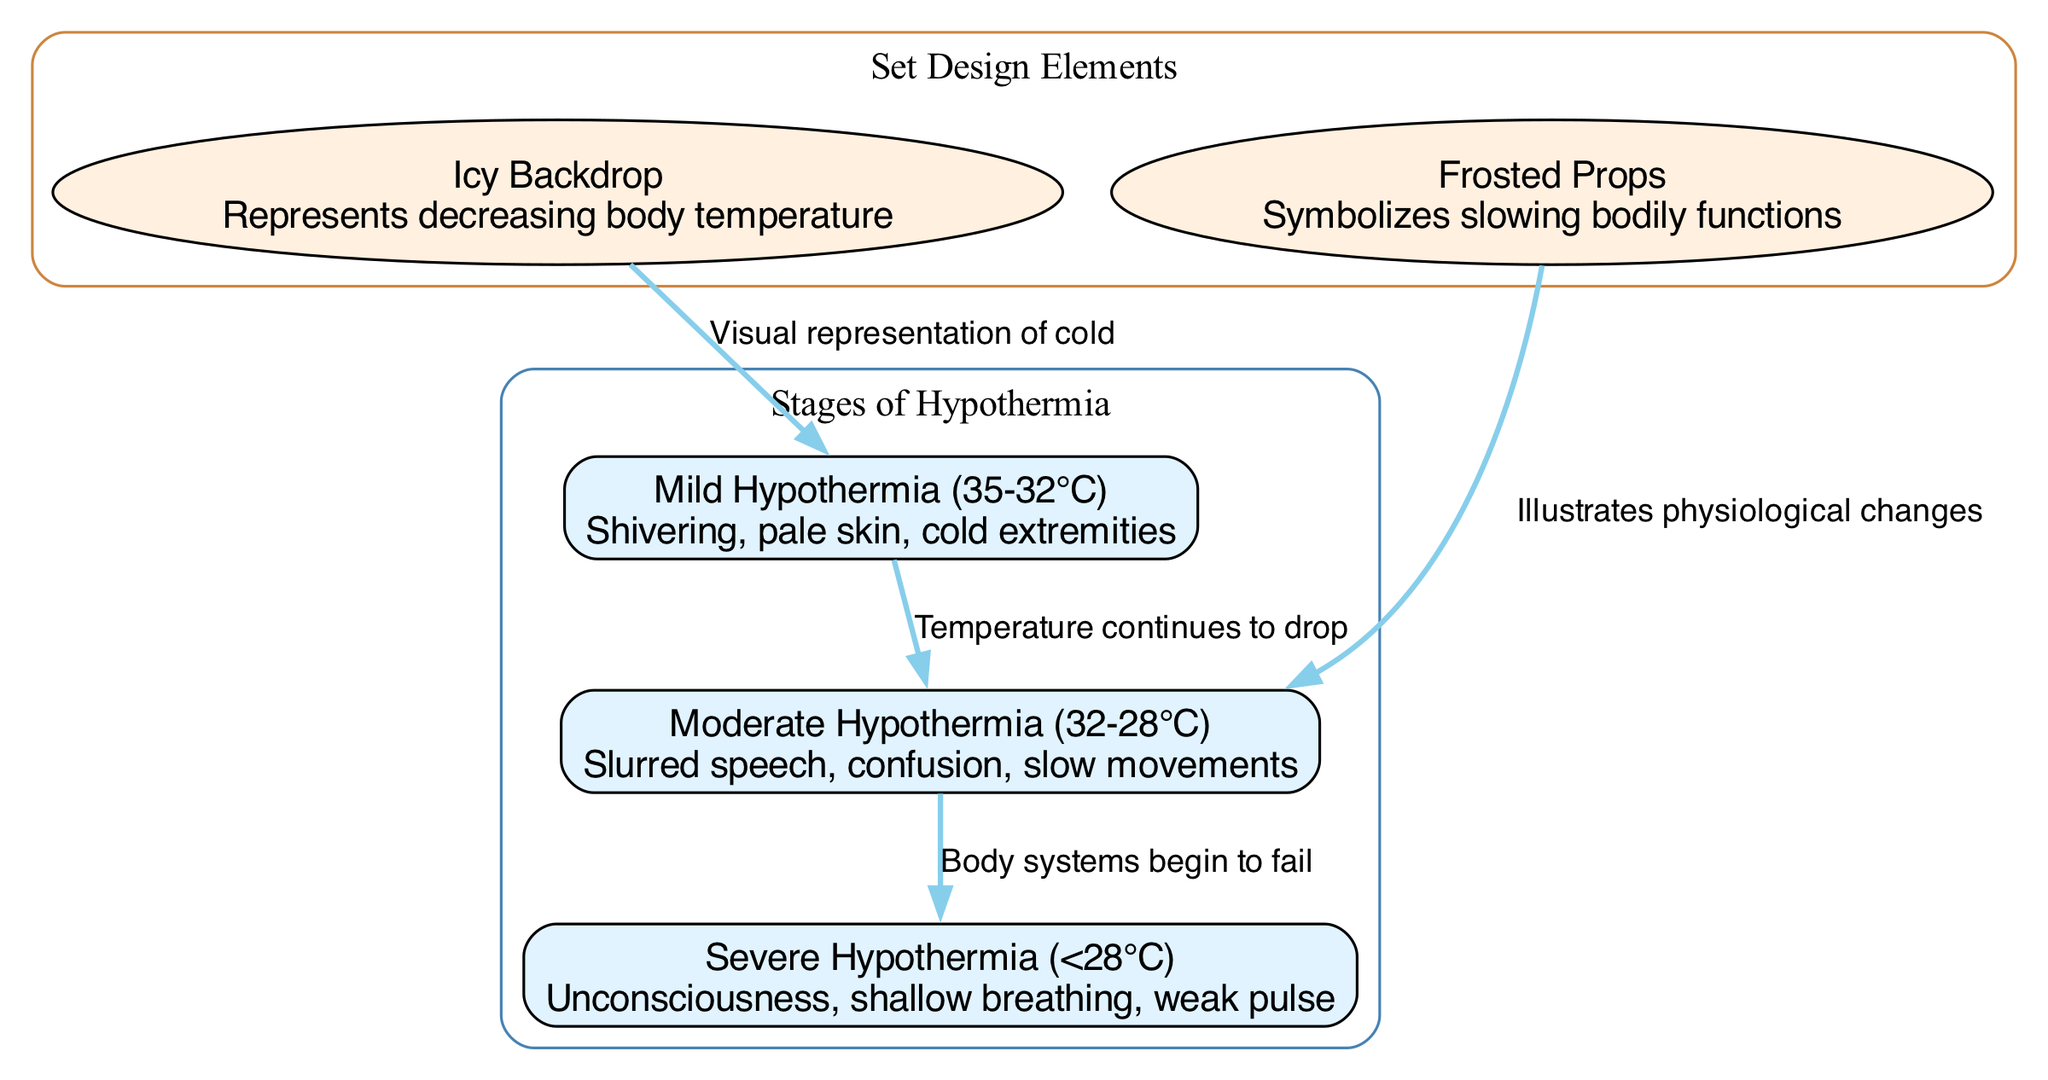What are the three stages of hypothermia illustrated in the diagram? The diagram lists three stages: Mild Hypothermia (35-32°C), Moderate Hypothermia (32-28°C), and Severe Hypothermia (<28°C).
Answer: Mild Hypothermia, Moderate Hypothermia, Severe Hypothermia What are the symptoms associated with Moderate Hypothermia? According to the diagram, Moderate Hypothermia is characterized by symptoms such as slurred speech, confusion, and slow movements.
Answer: Slurred speech, confusion, slow movements How many edges connect the stages of hypothermia? The diagram shows two edges: one from Mild Hypothermia to Moderate Hypothermia and another from Moderate Hypothermia to Severe Hypothermia.
Answer: 2 What visual element represents decreasing body temperature? The Icy Backdrop set design element is indicated in the diagram as a visual representation of decreasing body temperature.
Answer: Icy Backdrop What happens to body systems as temperature decreases to the Severe Hypothermia stage? The diagram indicates that as temperature decreases to Severe Hypothermia (<28°C), body systems begin to fail.
Answer: Body systems begin to fail What is the relationship between the Icy Backdrop and Mild Hypothermia? The diagram indicates that the Icy Backdrop visually represents the cold conditions associated with Mild Hypothermia.
Answer: Visual representation of cold In which stage of hypothermia is a weak pulse observed? The diagram states that a weak pulse is observed in the Severe Hypothermia stage, where symptoms include unconsciousness and shallow breathing.
Answer: Severe Hypothermia What do the Frosted Props symbolize in relation to the diagram? The Frosted Props are used in the diagram to symbolize the slowing of bodily functions as hypothermia progresses.
Answer: Slowing bodily functions What temperature range corresponds to Mild Hypothermia? According to the diagram, Mild Hypothermia corresponds to a temperature range of 35 to 32 degrees Celsius.
Answer: 35-32°C 